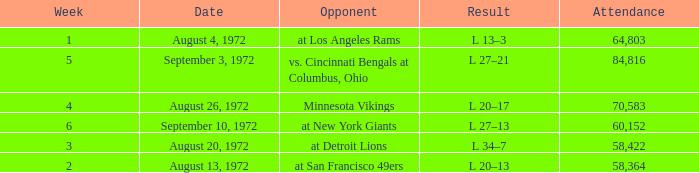Could you parse the entire table? {'header': ['Week', 'Date', 'Opponent', 'Result', 'Attendance'], 'rows': [['1', 'August 4, 1972', 'at Los Angeles Rams', 'L 13–3', '64,803'], ['5', 'September 3, 1972', 'vs. Cincinnati Bengals at Columbus, Ohio', 'L 27–21', '84,816'], ['4', 'August 26, 1972', 'Minnesota Vikings', 'L 20–17', '70,583'], ['6', 'September 10, 1972', 'at New York Giants', 'L 27–13', '60,152'], ['3', 'August 20, 1972', 'at Detroit Lions', 'L 34–7', '58,422'], ['2', 'August 13, 1972', 'at San Francisco 49ers', 'L 20–13', '58,364']]} What is the lowest attendance on September 3, 1972? 84816.0. 